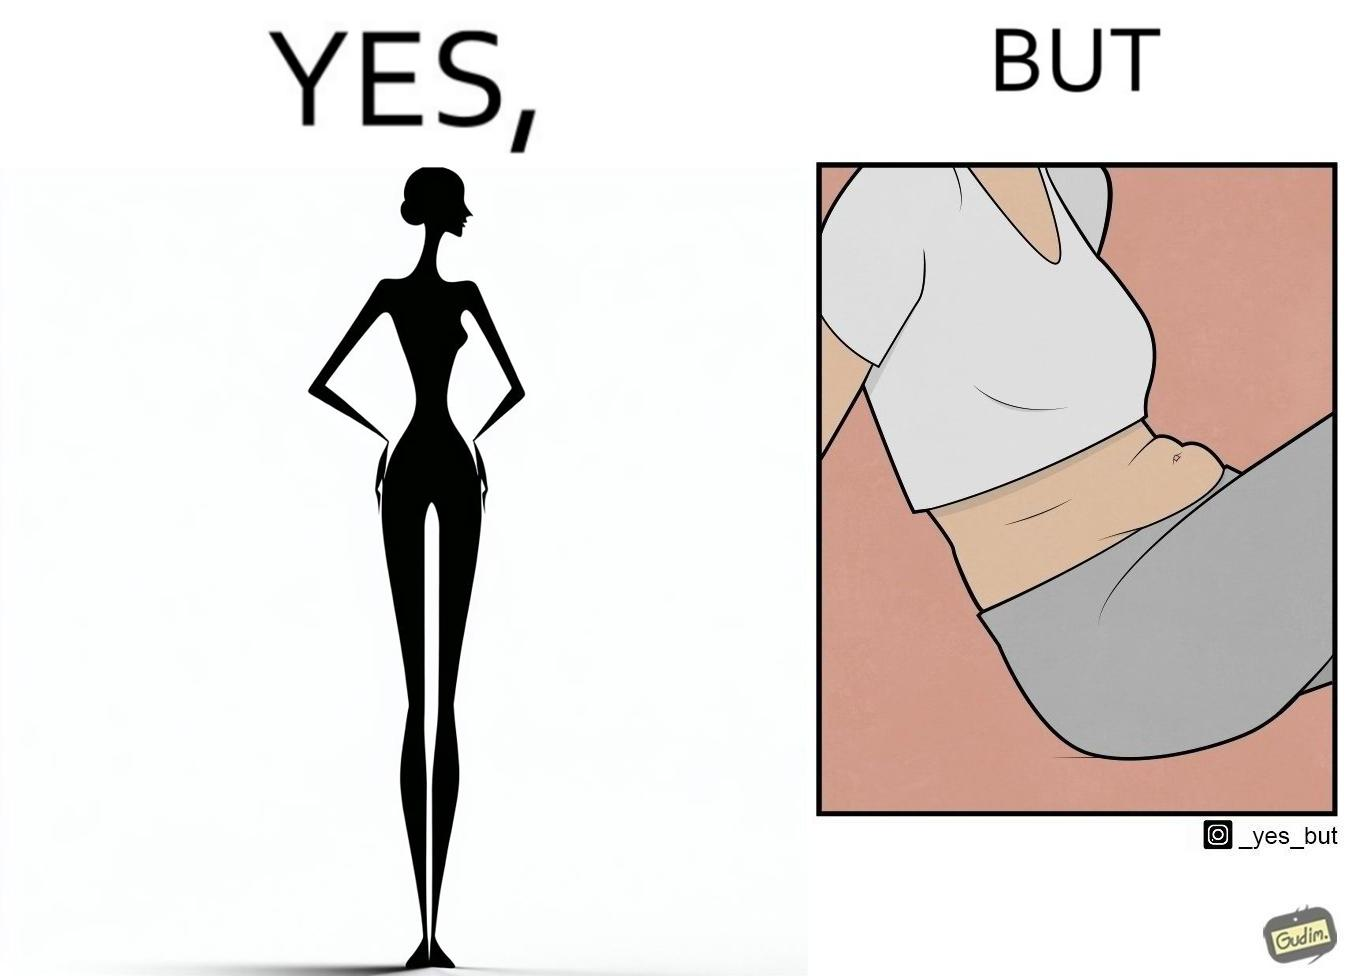Does this image contain satire or humor? Yes, this image is satirical. 